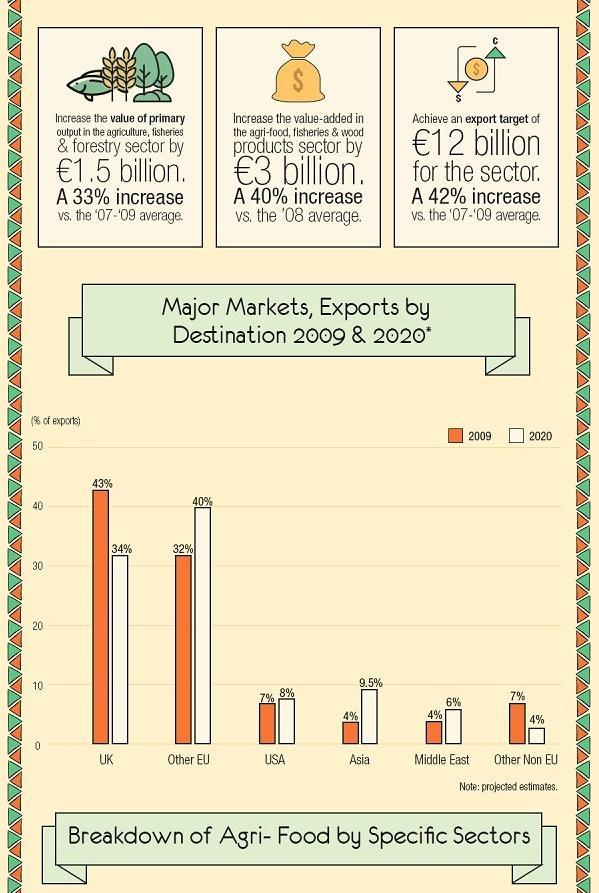Exports to which destination increased by 8% in the time period 2009-2020?
Answer the question with a short phrase. Other EU What was the percentage of increase in export target compared to 07-09? 42% To which destination was the percentage of export 4% in 2020? Other Non EU What was the % of exports to Middle East in 2020? 6% Exports to which destination fell by 9% in the time period 2009-2020? UK To which destination was the second highest % of export in 2009? Other EU What was the percentage of increase in the primary output value in agriculture, fisheries and forestry sector? 33% What was the % of exports to USA in 2009? 7% 